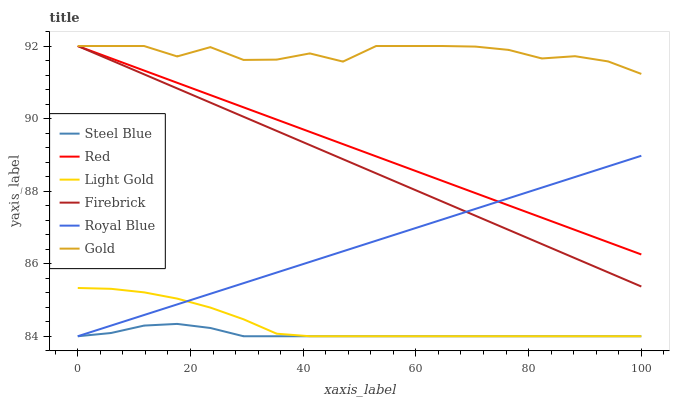Does Steel Blue have the minimum area under the curve?
Answer yes or no. Yes. Does Gold have the maximum area under the curve?
Answer yes or no. Yes. Does Firebrick have the minimum area under the curve?
Answer yes or no. No. Does Firebrick have the maximum area under the curve?
Answer yes or no. No. Is Firebrick the smoothest?
Answer yes or no. Yes. Is Gold the roughest?
Answer yes or no. Yes. Is Steel Blue the smoothest?
Answer yes or no. No. Is Steel Blue the roughest?
Answer yes or no. No. Does Steel Blue have the lowest value?
Answer yes or no. Yes. Does Firebrick have the lowest value?
Answer yes or no. No. Does Red have the highest value?
Answer yes or no. Yes. Does Steel Blue have the highest value?
Answer yes or no. No. Is Steel Blue less than Firebrick?
Answer yes or no. Yes. Is Gold greater than Steel Blue?
Answer yes or no. Yes. Does Firebrick intersect Gold?
Answer yes or no. Yes. Is Firebrick less than Gold?
Answer yes or no. No. Is Firebrick greater than Gold?
Answer yes or no. No. Does Steel Blue intersect Firebrick?
Answer yes or no. No. 